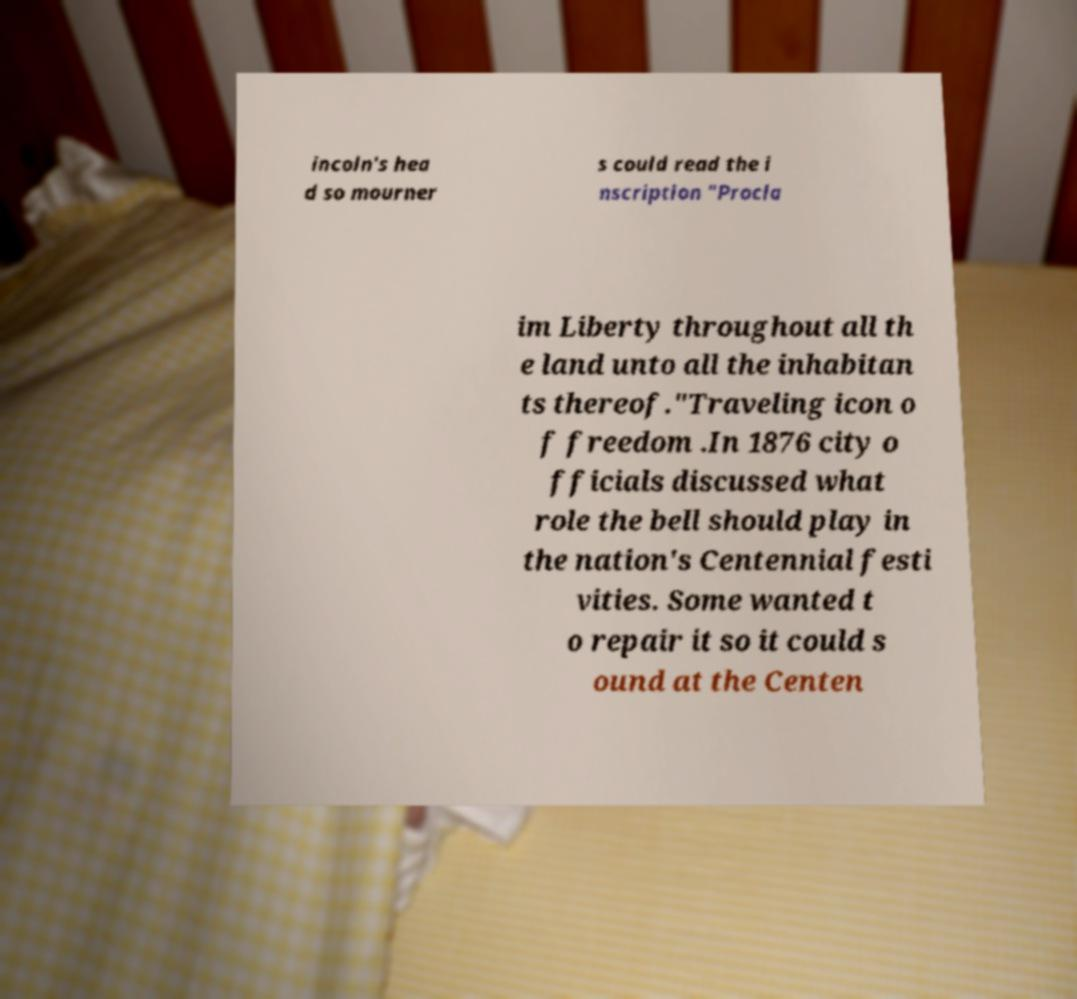Can you read and provide the text displayed in the image?This photo seems to have some interesting text. Can you extract and type it out for me? incoln's hea d so mourner s could read the i nscription "Procla im Liberty throughout all th e land unto all the inhabitan ts thereof."Traveling icon o f freedom .In 1876 city o fficials discussed what role the bell should play in the nation's Centennial festi vities. Some wanted t o repair it so it could s ound at the Centen 